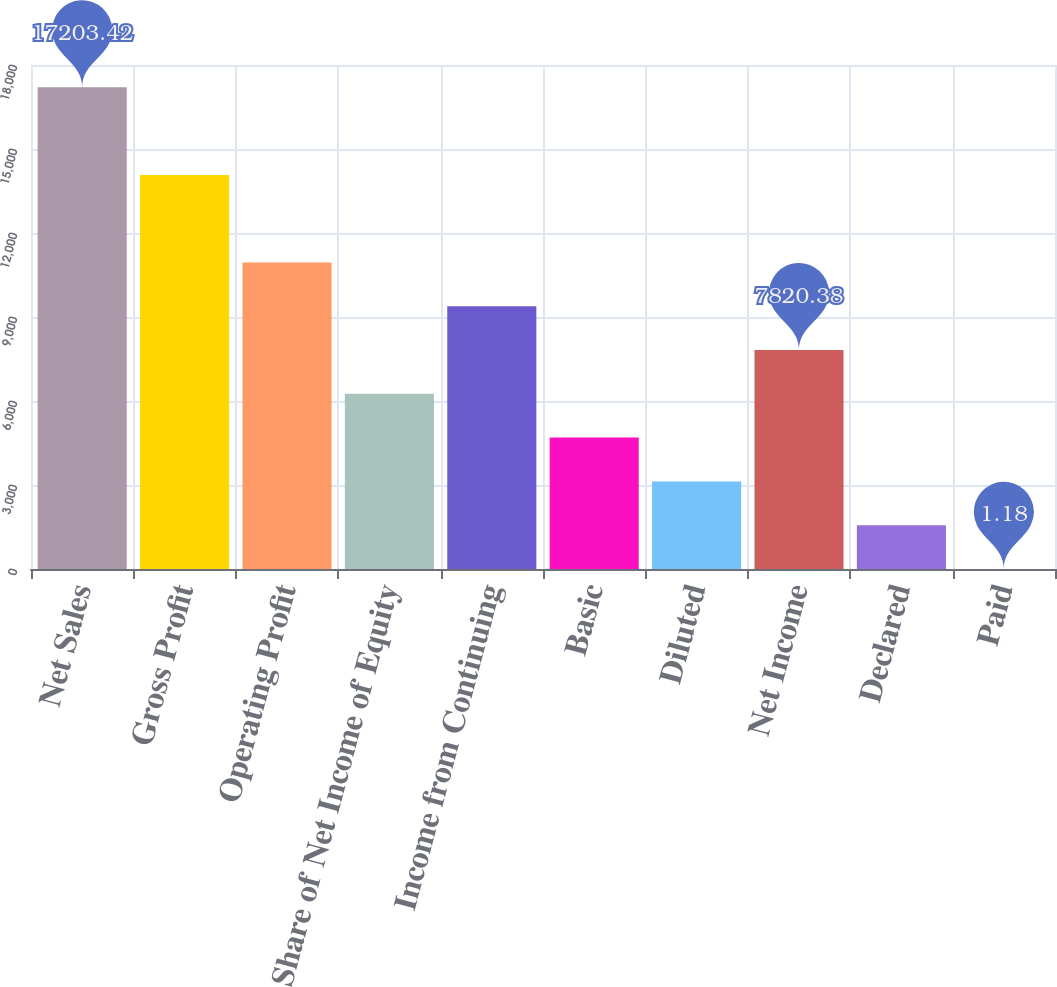Convert chart. <chart><loc_0><loc_0><loc_500><loc_500><bar_chart><fcel>Net Sales<fcel>Gross Profit<fcel>Operating Profit<fcel>Share of Net Income of Equity<fcel>Income from Continuing<fcel>Basic<fcel>Diluted<fcel>Net Income<fcel>Declared<fcel>Paid<nl><fcel>17203.4<fcel>14075.7<fcel>10948.1<fcel>6256.54<fcel>9384.22<fcel>4692.7<fcel>3128.86<fcel>7820.38<fcel>1565.02<fcel>1.18<nl></chart> 